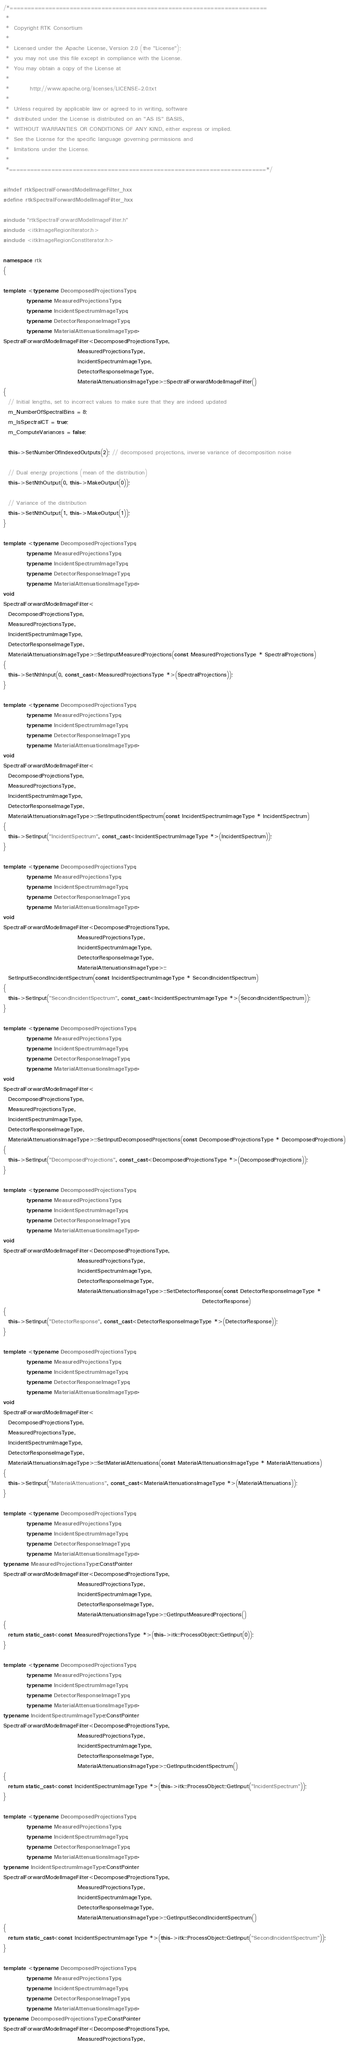<code> <loc_0><loc_0><loc_500><loc_500><_C++_>/*=========================================================================
 *
 *  Copyright RTK Consortium
 *
 *  Licensed under the Apache License, Version 2.0 (the "License");
 *  you may not use this file except in compliance with the License.
 *  You may obtain a copy of the License at
 *
 *         http://www.apache.org/licenses/LICENSE-2.0.txt
 *
 *  Unless required by applicable law or agreed to in writing, software
 *  distributed under the License is distributed on an "AS IS" BASIS,
 *  WITHOUT WARRANTIES OR CONDITIONS OF ANY KIND, either express or implied.
 *  See the License for the specific language governing permissions and
 *  limitations under the License.
 *
 *=========================================================================*/

#ifndef rtkSpectralForwardModelImageFilter_hxx
#define rtkSpectralForwardModelImageFilter_hxx

#include "rtkSpectralForwardModelImageFilter.h"
#include <itkImageRegionIterator.h>
#include <itkImageRegionConstIterator.h>

namespace rtk
{

template <typename DecomposedProjectionsType,
          typename MeasuredProjectionsType,
          typename IncidentSpectrumImageType,
          typename DetectorResponseImageType,
          typename MaterialAttenuationsImageType>
SpectralForwardModelImageFilter<DecomposedProjectionsType,
                                MeasuredProjectionsType,
                                IncidentSpectrumImageType,
                                DetectorResponseImageType,
                                MaterialAttenuationsImageType>::SpectralForwardModelImageFilter()
{
  // Initial lengths, set to incorrect values to make sure that they are indeed updated
  m_NumberOfSpectralBins = 8;
  m_IsSpectralCT = true;
  m_ComputeVariances = false;

  this->SetNumberOfIndexedOutputs(2); // decomposed projections, inverse variance of decomposition noise

  // Dual energy projections (mean of the distribution)
  this->SetNthOutput(0, this->MakeOutput(0));

  // Variance of the distribution
  this->SetNthOutput(1, this->MakeOutput(1));
}

template <typename DecomposedProjectionsType,
          typename MeasuredProjectionsType,
          typename IncidentSpectrumImageType,
          typename DetectorResponseImageType,
          typename MaterialAttenuationsImageType>
void
SpectralForwardModelImageFilter<
  DecomposedProjectionsType,
  MeasuredProjectionsType,
  IncidentSpectrumImageType,
  DetectorResponseImageType,
  MaterialAttenuationsImageType>::SetInputMeasuredProjections(const MeasuredProjectionsType * SpectralProjections)
{
  this->SetNthInput(0, const_cast<MeasuredProjectionsType *>(SpectralProjections));
}

template <typename DecomposedProjectionsType,
          typename MeasuredProjectionsType,
          typename IncidentSpectrumImageType,
          typename DetectorResponseImageType,
          typename MaterialAttenuationsImageType>
void
SpectralForwardModelImageFilter<
  DecomposedProjectionsType,
  MeasuredProjectionsType,
  IncidentSpectrumImageType,
  DetectorResponseImageType,
  MaterialAttenuationsImageType>::SetInputIncidentSpectrum(const IncidentSpectrumImageType * IncidentSpectrum)
{
  this->SetInput("IncidentSpectrum", const_cast<IncidentSpectrumImageType *>(IncidentSpectrum));
}

template <typename DecomposedProjectionsType,
          typename MeasuredProjectionsType,
          typename IncidentSpectrumImageType,
          typename DetectorResponseImageType,
          typename MaterialAttenuationsImageType>
void
SpectralForwardModelImageFilter<DecomposedProjectionsType,
                                MeasuredProjectionsType,
                                IncidentSpectrumImageType,
                                DetectorResponseImageType,
                                MaterialAttenuationsImageType>::
  SetInputSecondIncidentSpectrum(const IncidentSpectrumImageType * SecondIncidentSpectrum)
{
  this->SetInput("SecondIncidentSpectrum", const_cast<IncidentSpectrumImageType *>(SecondIncidentSpectrum));
}

template <typename DecomposedProjectionsType,
          typename MeasuredProjectionsType,
          typename IncidentSpectrumImageType,
          typename DetectorResponseImageType,
          typename MaterialAttenuationsImageType>
void
SpectralForwardModelImageFilter<
  DecomposedProjectionsType,
  MeasuredProjectionsType,
  IncidentSpectrumImageType,
  DetectorResponseImageType,
  MaterialAttenuationsImageType>::SetInputDecomposedProjections(const DecomposedProjectionsType * DecomposedProjections)
{
  this->SetInput("DecomposedProjections", const_cast<DecomposedProjectionsType *>(DecomposedProjections));
}

template <typename DecomposedProjectionsType,
          typename MeasuredProjectionsType,
          typename IncidentSpectrumImageType,
          typename DetectorResponseImageType,
          typename MaterialAttenuationsImageType>
void
SpectralForwardModelImageFilter<DecomposedProjectionsType,
                                MeasuredProjectionsType,
                                IncidentSpectrumImageType,
                                DetectorResponseImageType,
                                MaterialAttenuationsImageType>::SetDetectorResponse(const DetectorResponseImageType *
                                                                                      DetectorResponse)
{
  this->SetInput("DetectorResponse", const_cast<DetectorResponseImageType *>(DetectorResponse));
}

template <typename DecomposedProjectionsType,
          typename MeasuredProjectionsType,
          typename IncidentSpectrumImageType,
          typename DetectorResponseImageType,
          typename MaterialAttenuationsImageType>
void
SpectralForwardModelImageFilter<
  DecomposedProjectionsType,
  MeasuredProjectionsType,
  IncidentSpectrumImageType,
  DetectorResponseImageType,
  MaterialAttenuationsImageType>::SetMaterialAttenuations(const MaterialAttenuationsImageType * MaterialAttenuations)
{
  this->SetInput("MaterialAttenuations", const_cast<MaterialAttenuationsImageType *>(MaterialAttenuations));
}

template <typename DecomposedProjectionsType,
          typename MeasuredProjectionsType,
          typename IncidentSpectrumImageType,
          typename DetectorResponseImageType,
          typename MaterialAttenuationsImageType>
typename MeasuredProjectionsType::ConstPointer
SpectralForwardModelImageFilter<DecomposedProjectionsType,
                                MeasuredProjectionsType,
                                IncidentSpectrumImageType,
                                DetectorResponseImageType,
                                MaterialAttenuationsImageType>::GetInputMeasuredProjections()
{
  return static_cast<const MeasuredProjectionsType *>(this->itk::ProcessObject::GetInput(0));
}

template <typename DecomposedProjectionsType,
          typename MeasuredProjectionsType,
          typename IncidentSpectrumImageType,
          typename DetectorResponseImageType,
          typename MaterialAttenuationsImageType>
typename IncidentSpectrumImageType::ConstPointer
SpectralForwardModelImageFilter<DecomposedProjectionsType,
                                MeasuredProjectionsType,
                                IncidentSpectrumImageType,
                                DetectorResponseImageType,
                                MaterialAttenuationsImageType>::GetInputIncidentSpectrum()
{
  return static_cast<const IncidentSpectrumImageType *>(this->itk::ProcessObject::GetInput("IncidentSpectrum"));
}

template <typename DecomposedProjectionsType,
          typename MeasuredProjectionsType,
          typename IncidentSpectrumImageType,
          typename DetectorResponseImageType,
          typename MaterialAttenuationsImageType>
typename IncidentSpectrumImageType::ConstPointer
SpectralForwardModelImageFilter<DecomposedProjectionsType,
                                MeasuredProjectionsType,
                                IncidentSpectrumImageType,
                                DetectorResponseImageType,
                                MaterialAttenuationsImageType>::GetInputSecondIncidentSpectrum()
{
  return static_cast<const IncidentSpectrumImageType *>(this->itk::ProcessObject::GetInput("SecondIncidentSpectrum"));
}

template <typename DecomposedProjectionsType,
          typename MeasuredProjectionsType,
          typename IncidentSpectrumImageType,
          typename DetectorResponseImageType,
          typename MaterialAttenuationsImageType>
typename DecomposedProjectionsType::ConstPointer
SpectralForwardModelImageFilter<DecomposedProjectionsType,
                                MeasuredProjectionsType,</code> 